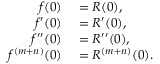Convert formula to latex. <formula><loc_0><loc_0><loc_500><loc_500>\begin{array} { r l } { f ( 0 ) } & = R ( 0 ) , } \\ { f ^ { \prime } ( 0 ) } & = R ^ { \prime } ( 0 ) , } \\ { f ^ { \prime \prime } ( 0 ) } & = R ^ { \prime \prime } ( 0 ) , } \\ { f ^ { ( m + n ) } ( 0 ) } & = R ^ { ( m + n ) } ( 0 ) . } \end{array}</formula> 